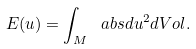Convert formula to latex. <formula><loc_0><loc_0><loc_500><loc_500>E ( u ) = \int _ { M } \ a b s { d u } ^ { 2 } d V o l .</formula> 